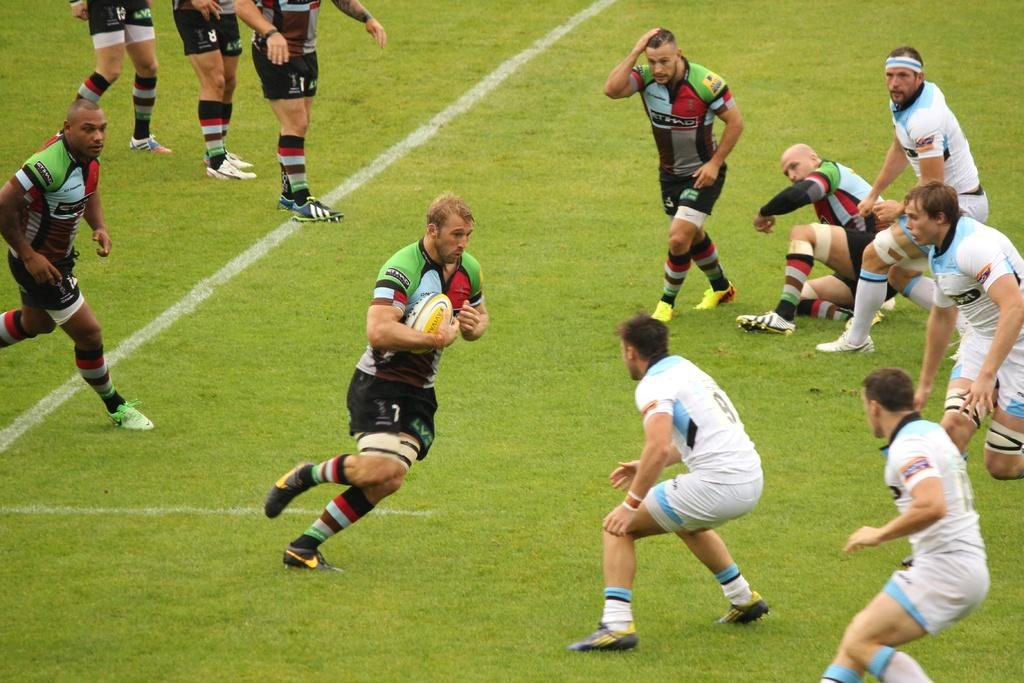<image>
Render a clear and concise summary of the photo. a player in white with the number 9 on their jersey 